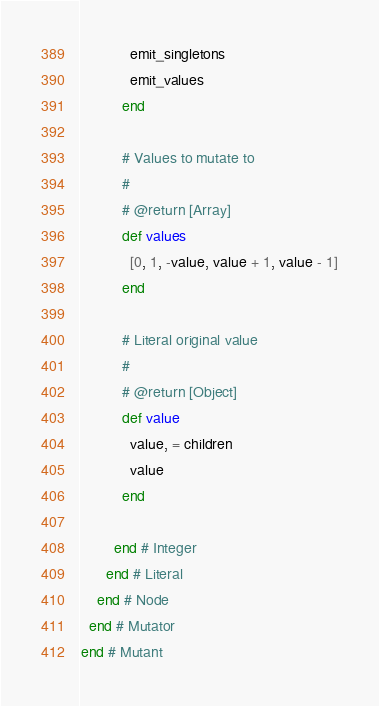<code> <loc_0><loc_0><loc_500><loc_500><_Ruby_>            emit_singletons
            emit_values
          end

          # Values to mutate to
          #
          # @return [Array]
          def values
            [0, 1, -value, value + 1, value - 1]
          end

          # Literal original value
          #
          # @return [Object]
          def value
            value, = children
            value
          end

        end # Integer
      end # Literal
    end # Node
  end # Mutator
end # Mutant
</code> 